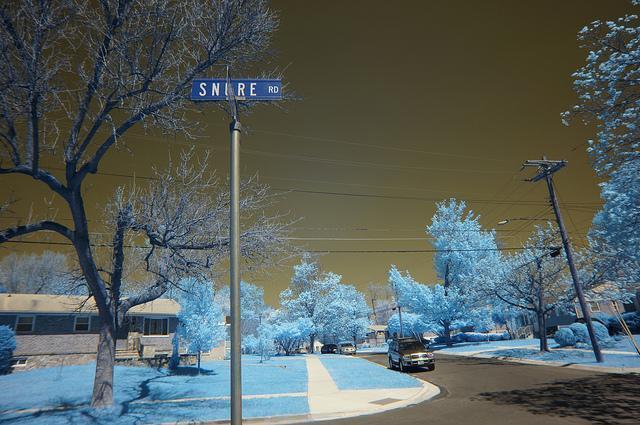How many power poles are visible?
Give a very brief answer. 1. How many laptops are on the desk?
Give a very brief answer. 0. 